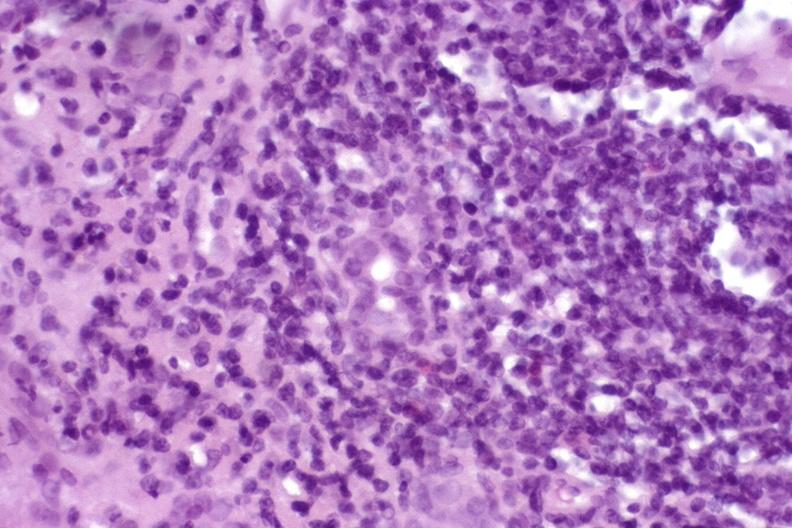does this image show autoimmune hepatitis?
Answer the question using a single word or phrase. Yes 